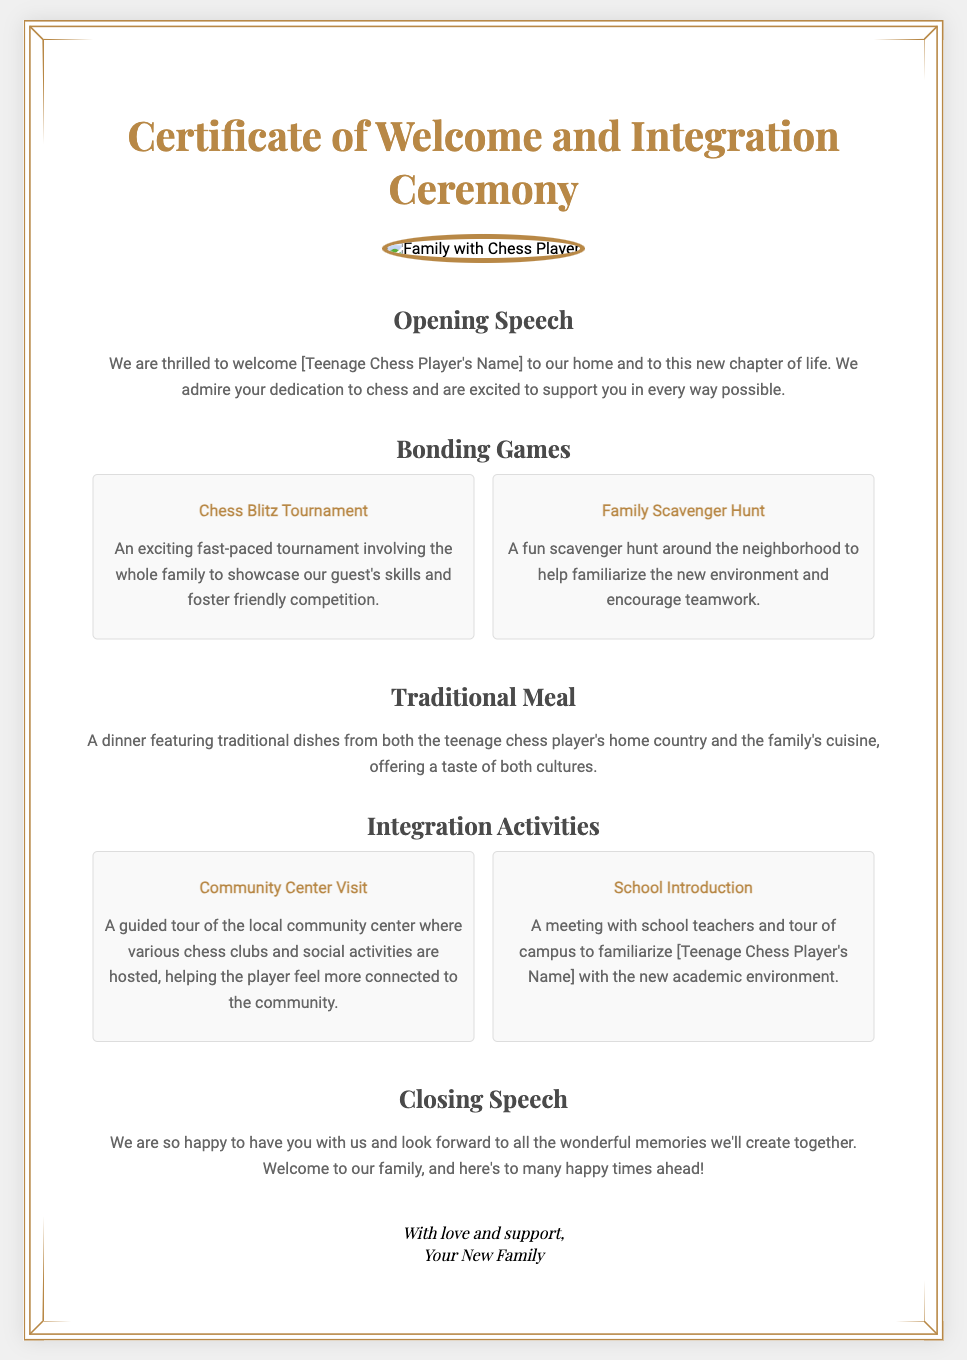What is the title of the document? The title is prominently displayed at the top of the certificate.
Answer: Certificate of Welcome and Integration Ceremony Who is the certificate for? The certificate features a section that includes the name of the guest being welcomed.
Answer: [Teenage Chess Player's Name] What is one of the bonding games mentioned? The document lists activities under bonding games, showcasing family engagement and enjoyment.
Answer: Chess Blitz Tournament What type of meal is included in the ceremony? A specific section outlines the culinary aspect of the welcome.
Answer: Traditional Meal What activity helps familiarize the new environment? The document includes various activities that aim to help the teenage chess player adjust and integrate.
Answer: Family Scavenger Hunt What is discussed in the opening speech? The opening speech sets the tone for the welcome event and expresses sentiment towards the guest.
Answer: Thrilled to welcome [Teenage Chess Player's Name] What is one of the integration activities listed? The document presents several integration-related activities aimed at helping the teenage chess player feel connected.
Answer: Community Center Visit What does the closing speech express? The closing speech summarizes the overall sentiment of the event toward the teenage chess player.
Answer: Welcome to our family How many bonding games are mentioned? The document specifies the number of bonding games organized for the welcome.
Answer: Two 